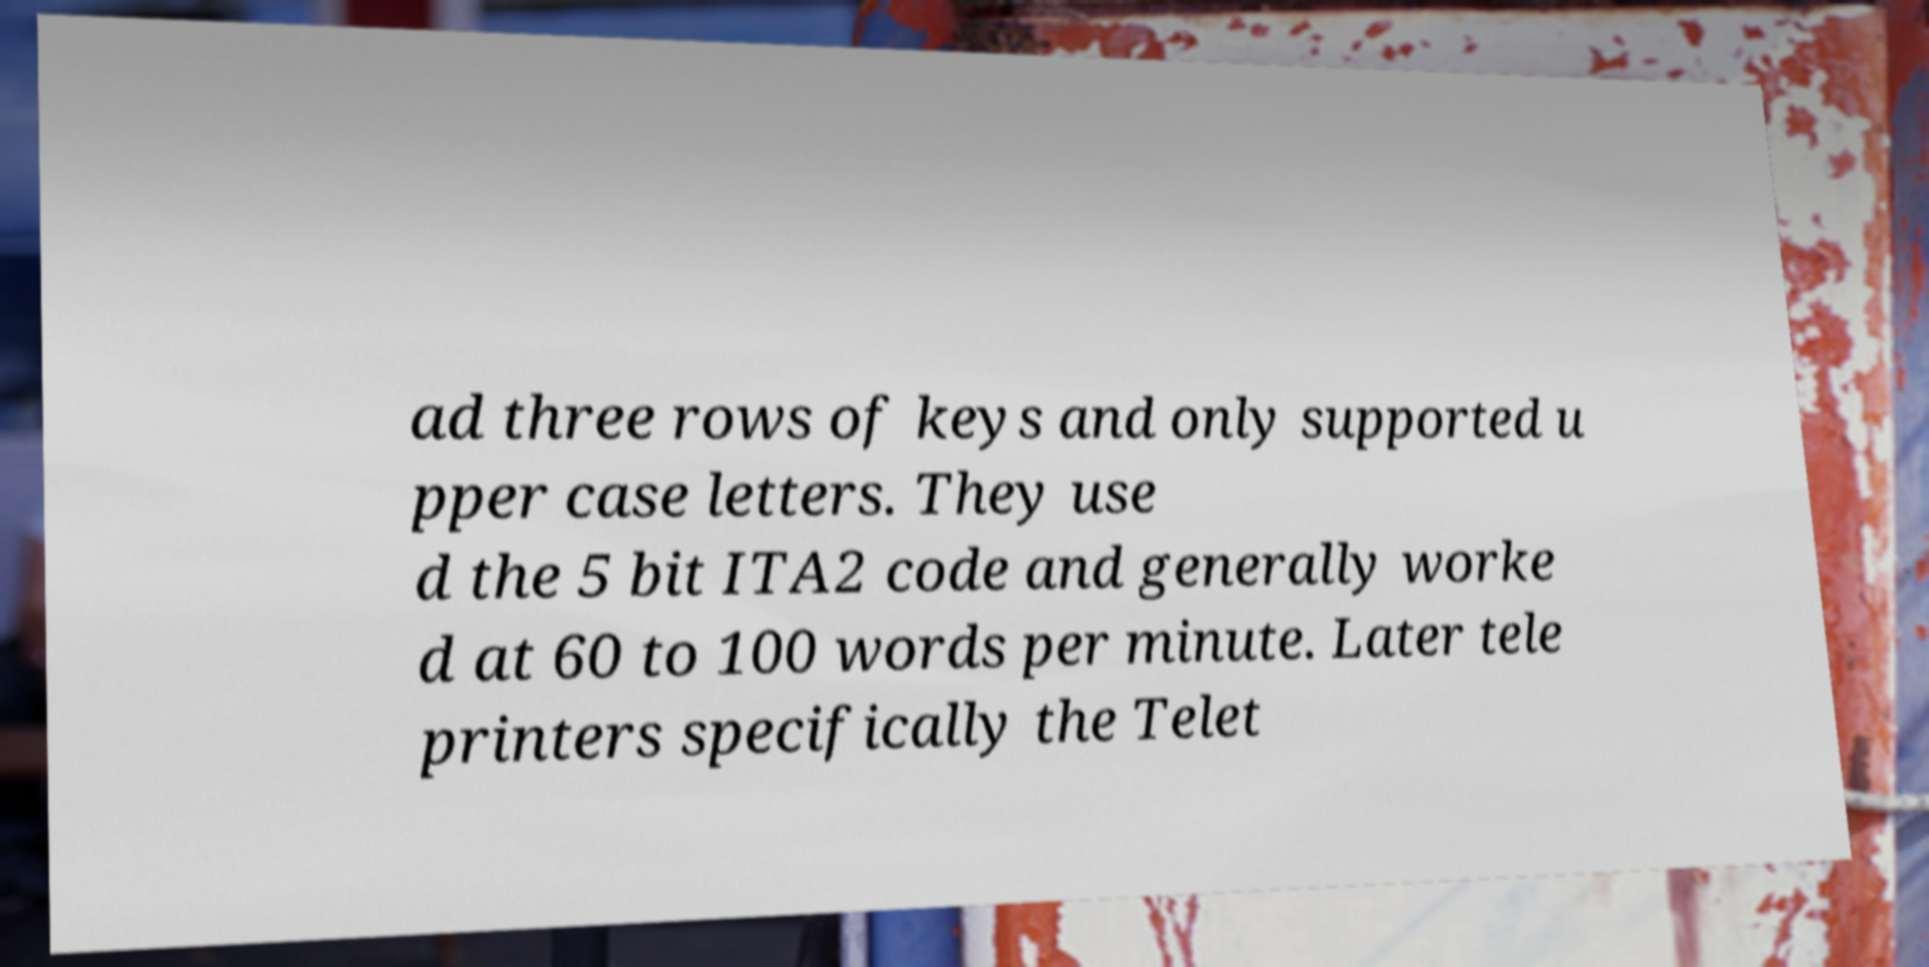Please read and relay the text visible in this image. What does it say? ad three rows of keys and only supported u pper case letters. They use d the 5 bit ITA2 code and generally worke d at 60 to 100 words per minute. Later tele printers specifically the Telet 